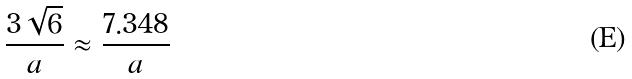<formula> <loc_0><loc_0><loc_500><loc_500>\frac { 3 \sqrt { 6 } } { a } \approx \frac { 7 . 3 4 8 } { a }</formula> 